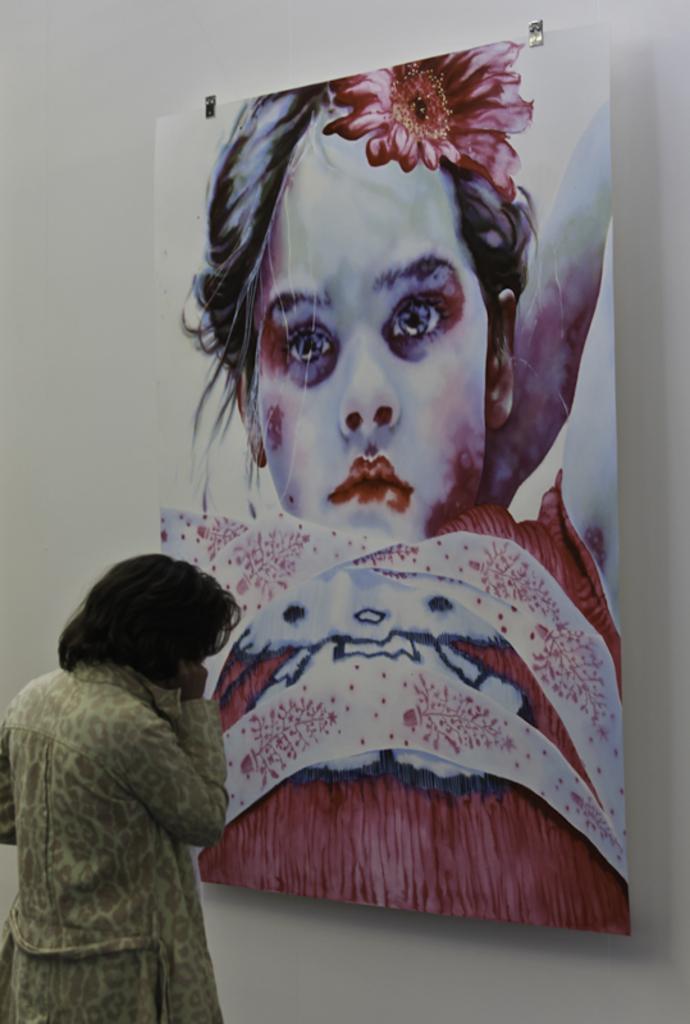In one or two sentences, can you explain what this image depicts? In this image we can see a lady. There is a painting on the wall. 